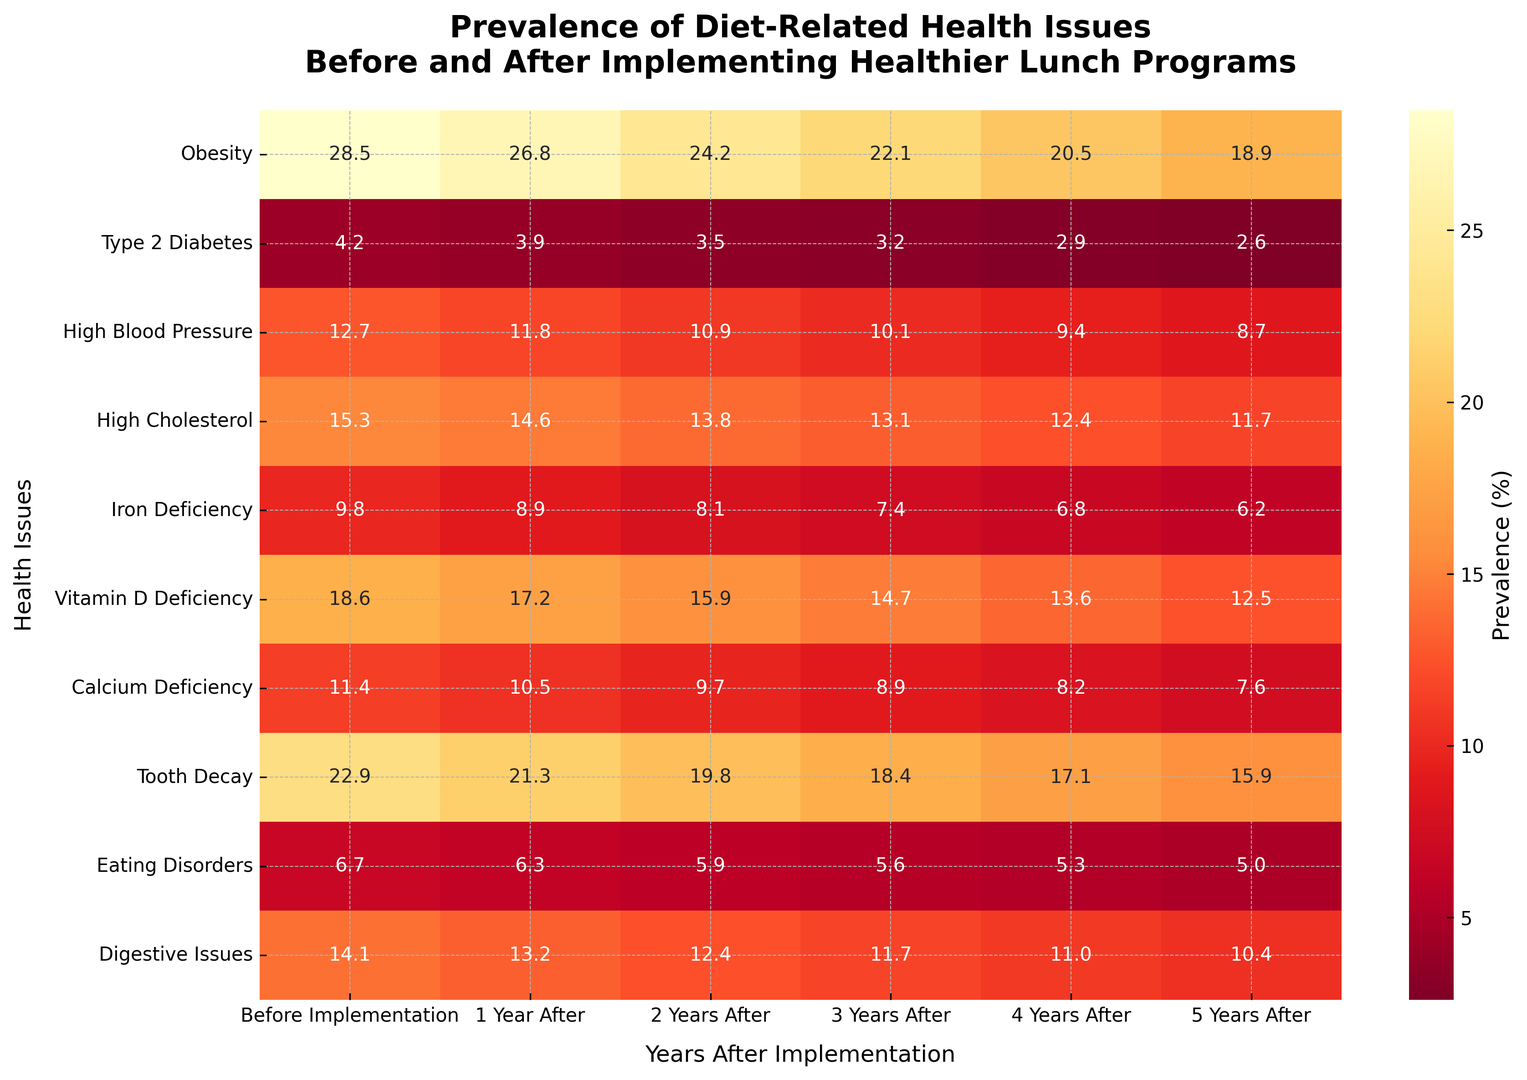What is the difference in the prevalence of Obesity between the first and fifth year after implementation? To find the difference, we simply subtract the prevalence of Obesity in the fifth year (18.9%) from that in the first year (26.8%). This gives us: 26.8% - 18.9% = 7.9%.
Answer: 7.9% What health issue shows the most significant decrease in prevalence after five years of implementing healthier lunch programs? By examining the differences in prevalence before implementation and five years after for each health issue, we need to identify which one has the highest absolute difference. By inspection, Obesity shows a decrease from 28.5% to 18.9%, a drop of 9.6%, which is the highest.
Answer: Obesity Which health issue had the highest prevalence before the implementation of the healthier lunch programs? We need to look at the "Before Implementation" column and identify the highest value. The highest percentage is for Obesity at 28.5%.
Answer: Obesity What is the average prevalence of Type 2 Diabetes over the six time points shown? To find the average, sum the values and divide by the number of time points: (4.2 + 3.9 + 3.5 + 3.2 + 2.9 + 2.6) = 20.3, then divide by 6 which equals 20.3 / 6 ≈ 3.38%.
Answer: 3.38% Which diet-related health issue had the lowest prevalence five years after the implementation? We need to find the smallest value in the "5 Years After" column. The smallest value is Type 2 Diabetes at 2.6%.
Answer: Type 2 Diabetes Was the prevalence of High Blood Pressure higher or lower than Iron Deficiency three years after program implementation? Compare the values in the "3 Years After" column for High Blood Pressure (10.1%) and Iron Deficiency (7.4%). High Blood Pressure is higher.
Answer: Higher What is the trend in the prevalence of Vitamin D Deficiency over the years shown in the heatmap? By observing the values for Vitamin D Deficiency, we notice a consistent decrease: 18.6% > 17.2% > 15.9% > 14.7% > 13.6% > 12.5%. This indicates a decreasing trend.
Answer: Decreasing Which health issue had a greater reduction after two years: Digestive Issues or Eating Disorders? Calculate the reduction for each: Digestive Issues: 14.1% to 12.4%, a reduction of 1.7%. Eating Disorders: 6.7% to 5.9%, a reduction of 0.8%. Digestive Issues had a greater reduction.
Answer: Digestive Issues How many health issues had their prevalence below 10% five years after implementation? By examining the "5 Years After" column, the health issues with prevalence below 10% are Type 2 Diabetes (2.6%), High Blood Pressure (8.7%), Iron Deficiency (6.2%), Calcium Deficiency (7.6%), and Eating Disorders (5.0%). There are 5 such health issues.
Answer: 5 